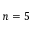<formula> <loc_0><loc_0><loc_500><loc_500>n = 5</formula> 